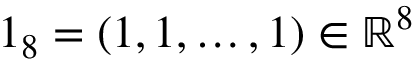Convert formula to latex. <formula><loc_0><loc_0><loc_500><loc_500>1 _ { 8 } = ( 1 , 1 , \dots , 1 ) \in \mathbb { R } ^ { 8 }</formula> 